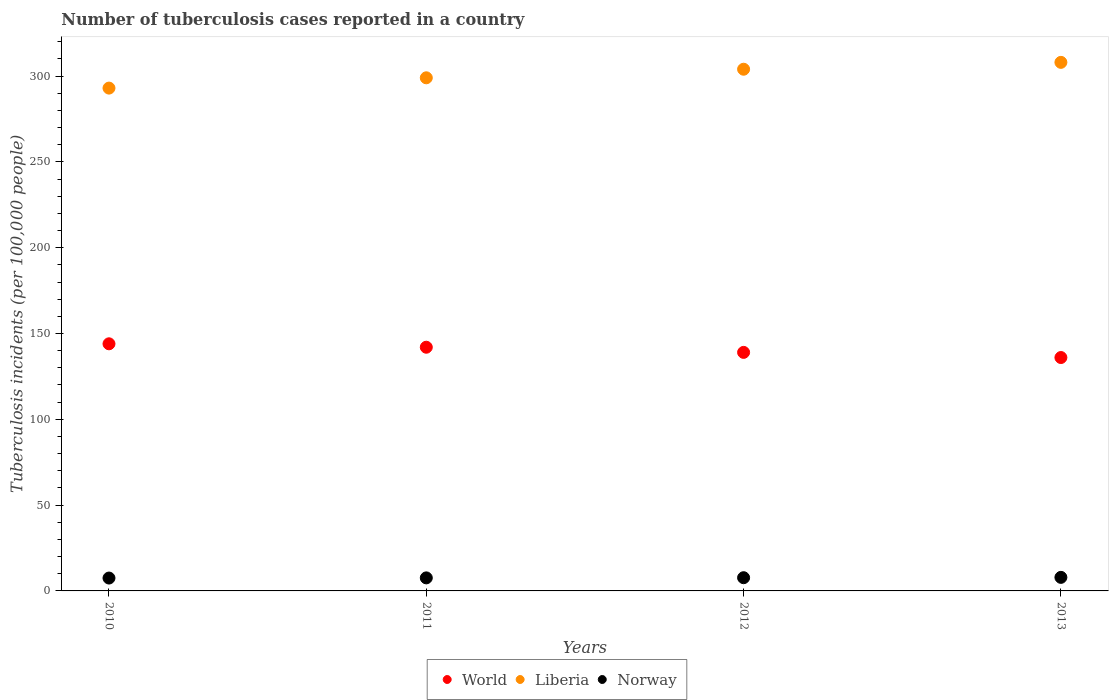How many different coloured dotlines are there?
Ensure brevity in your answer.  3. Across all years, what is the maximum number of tuberculosis cases reported in in Liberia?
Make the answer very short. 308. Across all years, what is the minimum number of tuberculosis cases reported in in Norway?
Keep it short and to the point. 7.5. In which year was the number of tuberculosis cases reported in in Liberia maximum?
Your response must be concise. 2013. What is the total number of tuberculosis cases reported in in World in the graph?
Offer a very short reply. 561. What is the difference between the number of tuberculosis cases reported in in Liberia in 2010 and that in 2012?
Give a very brief answer. -11. What is the difference between the number of tuberculosis cases reported in in Norway in 2013 and the number of tuberculosis cases reported in in Liberia in 2012?
Make the answer very short. -296.1. What is the average number of tuberculosis cases reported in in Liberia per year?
Your answer should be very brief. 301. In the year 2012, what is the difference between the number of tuberculosis cases reported in in Norway and number of tuberculosis cases reported in in Liberia?
Your response must be concise. -296.3. What is the ratio of the number of tuberculosis cases reported in in World in 2010 to that in 2013?
Offer a terse response. 1.06. What is the difference between the highest and the second highest number of tuberculosis cases reported in in Norway?
Give a very brief answer. 0.2. What is the difference between the highest and the lowest number of tuberculosis cases reported in in Norway?
Offer a terse response. 0.4. In how many years, is the number of tuberculosis cases reported in in Liberia greater than the average number of tuberculosis cases reported in in Liberia taken over all years?
Your answer should be compact. 2. Is the sum of the number of tuberculosis cases reported in in Liberia in 2011 and 2013 greater than the maximum number of tuberculosis cases reported in in World across all years?
Your response must be concise. Yes. Is the number of tuberculosis cases reported in in Liberia strictly less than the number of tuberculosis cases reported in in World over the years?
Provide a succinct answer. No. How many dotlines are there?
Make the answer very short. 3. How many years are there in the graph?
Make the answer very short. 4. Are the values on the major ticks of Y-axis written in scientific E-notation?
Your response must be concise. No. Does the graph contain any zero values?
Your response must be concise. No. Where does the legend appear in the graph?
Make the answer very short. Bottom center. How many legend labels are there?
Keep it short and to the point. 3. How are the legend labels stacked?
Make the answer very short. Horizontal. What is the title of the graph?
Ensure brevity in your answer.  Number of tuberculosis cases reported in a country. Does "Lower middle income" appear as one of the legend labels in the graph?
Provide a succinct answer. No. What is the label or title of the X-axis?
Give a very brief answer. Years. What is the label or title of the Y-axis?
Provide a short and direct response. Tuberculosis incidents (per 100,0 people). What is the Tuberculosis incidents (per 100,000 people) in World in 2010?
Your answer should be compact. 144. What is the Tuberculosis incidents (per 100,000 people) in Liberia in 2010?
Offer a very short reply. 293. What is the Tuberculosis incidents (per 100,000 people) of World in 2011?
Provide a short and direct response. 142. What is the Tuberculosis incidents (per 100,000 people) in Liberia in 2011?
Provide a succinct answer. 299. What is the Tuberculosis incidents (per 100,000 people) in World in 2012?
Give a very brief answer. 139. What is the Tuberculosis incidents (per 100,000 people) of Liberia in 2012?
Ensure brevity in your answer.  304. What is the Tuberculosis incidents (per 100,000 people) of Norway in 2012?
Your answer should be very brief. 7.7. What is the Tuberculosis incidents (per 100,000 people) in World in 2013?
Offer a terse response. 136. What is the Tuberculosis incidents (per 100,000 people) of Liberia in 2013?
Give a very brief answer. 308. Across all years, what is the maximum Tuberculosis incidents (per 100,000 people) in World?
Offer a very short reply. 144. Across all years, what is the maximum Tuberculosis incidents (per 100,000 people) in Liberia?
Offer a terse response. 308. Across all years, what is the maximum Tuberculosis incidents (per 100,000 people) of Norway?
Keep it short and to the point. 7.9. Across all years, what is the minimum Tuberculosis incidents (per 100,000 people) in World?
Make the answer very short. 136. Across all years, what is the minimum Tuberculosis incidents (per 100,000 people) of Liberia?
Make the answer very short. 293. Across all years, what is the minimum Tuberculosis incidents (per 100,000 people) of Norway?
Your answer should be very brief. 7.5. What is the total Tuberculosis incidents (per 100,000 people) in World in the graph?
Keep it short and to the point. 561. What is the total Tuberculosis incidents (per 100,000 people) of Liberia in the graph?
Offer a very short reply. 1204. What is the total Tuberculosis incidents (per 100,000 people) of Norway in the graph?
Your answer should be compact. 30.7. What is the difference between the Tuberculosis incidents (per 100,000 people) of World in 2010 and that in 2011?
Your answer should be very brief. 2. What is the difference between the Tuberculosis incidents (per 100,000 people) in Liberia in 2010 and that in 2011?
Your answer should be compact. -6. What is the difference between the Tuberculosis incidents (per 100,000 people) in Liberia in 2010 and that in 2012?
Your response must be concise. -11. What is the difference between the Tuberculosis incidents (per 100,000 people) in Norway in 2010 and that in 2012?
Make the answer very short. -0.2. What is the difference between the Tuberculosis incidents (per 100,000 people) of Norway in 2010 and that in 2013?
Make the answer very short. -0.4. What is the difference between the Tuberculosis incidents (per 100,000 people) of Liberia in 2011 and that in 2012?
Offer a very short reply. -5. What is the difference between the Tuberculosis incidents (per 100,000 people) in World in 2011 and that in 2013?
Ensure brevity in your answer.  6. What is the difference between the Tuberculosis incidents (per 100,000 people) in Liberia in 2011 and that in 2013?
Your answer should be very brief. -9. What is the difference between the Tuberculosis incidents (per 100,000 people) of World in 2010 and the Tuberculosis incidents (per 100,000 people) of Liberia in 2011?
Keep it short and to the point. -155. What is the difference between the Tuberculosis incidents (per 100,000 people) in World in 2010 and the Tuberculosis incidents (per 100,000 people) in Norway in 2011?
Your response must be concise. 136.4. What is the difference between the Tuberculosis incidents (per 100,000 people) in Liberia in 2010 and the Tuberculosis incidents (per 100,000 people) in Norway in 2011?
Provide a short and direct response. 285.4. What is the difference between the Tuberculosis incidents (per 100,000 people) of World in 2010 and the Tuberculosis incidents (per 100,000 people) of Liberia in 2012?
Offer a very short reply. -160. What is the difference between the Tuberculosis incidents (per 100,000 people) of World in 2010 and the Tuberculosis incidents (per 100,000 people) of Norway in 2012?
Provide a succinct answer. 136.3. What is the difference between the Tuberculosis incidents (per 100,000 people) in Liberia in 2010 and the Tuberculosis incidents (per 100,000 people) in Norway in 2012?
Provide a short and direct response. 285.3. What is the difference between the Tuberculosis incidents (per 100,000 people) in World in 2010 and the Tuberculosis incidents (per 100,000 people) in Liberia in 2013?
Make the answer very short. -164. What is the difference between the Tuberculosis incidents (per 100,000 people) of World in 2010 and the Tuberculosis incidents (per 100,000 people) of Norway in 2013?
Provide a succinct answer. 136.1. What is the difference between the Tuberculosis incidents (per 100,000 people) in Liberia in 2010 and the Tuberculosis incidents (per 100,000 people) in Norway in 2013?
Provide a succinct answer. 285.1. What is the difference between the Tuberculosis incidents (per 100,000 people) in World in 2011 and the Tuberculosis incidents (per 100,000 people) in Liberia in 2012?
Give a very brief answer. -162. What is the difference between the Tuberculosis incidents (per 100,000 people) of World in 2011 and the Tuberculosis incidents (per 100,000 people) of Norway in 2012?
Your answer should be very brief. 134.3. What is the difference between the Tuberculosis incidents (per 100,000 people) of Liberia in 2011 and the Tuberculosis incidents (per 100,000 people) of Norway in 2012?
Your answer should be very brief. 291.3. What is the difference between the Tuberculosis incidents (per 100,000 people) of World in 2011 and the Tuberculosis incidents (per 100,000 people) of Liberia in 2013?
Your answer should be compact. -166. What is the difference between the Tuberculosis incidents (per 100,000 people) in World in 2011 and the Tuberculosis incidents (per 100,000 people) in Norway in 2013?
Ensure brevity in your answer.  134.1. What is the difference between the Tuberculosis incidents (per 100,000 people) of Liberia in 2011 and the Tuberculosis incidents (per 100,000 people) of Norway in 2013?
Give a very brief answer. 291.1. What is the difference between the Tuberculosis incidents (per 100,000 people) of World in 2012 and the Tuberculosis incidents (per 100,000 people) of Liberia in 2013?
Your answer should be compact. -169. What is the difference between the Tuberculosis incidents (per 100,000 people) of World in 2012 and the Tuberculosis incidents (per 100,000 people) of Norway in 2013?
Keep it short and to the point. 131.1. What is the difference between the Tuberculosis incidents (per 100,000 people) of Liberia in 2012 and the Tuberculosis incidents (per 100,000 people) of Norway in 2013?
Make the answer very short. 296.1. What is the average Tuberculosis incidents (per 100,000 people) in World per year?
Give a very brief answer. 140.25. What is the average Tuberculosis incidents (per 100,000 people) of Liberia per year?
Make the answer very short. 301. What is the average Tuberculosis incidents (per 100,000 people) of Norway per year?
Give a very brief answer. 7.67. In the year 2010, what is the difference between the Tuberculosis incidents (per 100,000 people) in World and Tuberculosis incidents (per 100,000 people) in Liberia?
Give a very brief answer. -149. In the year 2010, what is the difference between the Tuberculosis incidents (per 100,000 people) of World and Tuberculosis incidents (per 100,000 people) of Norway?
Provide a succinct answer. 136.5. In the year 2010, what is the difference between the Tuberculosis incidents (per 100,000 people) of Liberia and Tuberculosis incidents (per 100,000 people) of Norway?
Your answer should be compact. 285.5. In the year 2011, what is the difference between the Tuberculosis incidents (per 100,000 people) of World and Tuberculosis incidents (per 100,000 people) of Liberia?
Your response must be concise. -157. In the year 2011, what is the difference between the Tuberculosis incidents (per 100,000 people) in World and Tuberculosis incidents (per 100,000 people) in Norway?
Your answer should be compact. 134.4. In the year 2011, what is the difference between the Tuberculosis incidents (per 100,000 people) of Liberia and Tuberculosis incidents (per 100,000 people) of Norway?
Give a very brief answer. 291.4. In the year 2012, what is the difference between the Tuberculosis incidents (per 100,000 people) of World and Tuberculosis incidents (per 100,000 people) of Liberia?
Keep it short and to the point. -165. In the year 2012, what is the difference between the Tuberculosis incidents (per 100,000 people) in World and Tuberculosis incidents (per 100,000 people) in Norway?
Keep it short and to the point. 131.3. In the year 2012, what is the difference between the Tuberculosis incidents (per 100,000 people) in Liberia and Tuberculosis incidents (per 100,000 people) in Norway?
Give a very brief answer. 296.3. In the year 2013, what is the difference between the Tuberculosis incidents (per 100,000 people) in World and Tuberculosis incidents (per 100,000 people) in Liberia?
Your response must be concise. -172. In the year 2013, what is the difference between the Tuberculosis incidents (per 100,000 people) in World and Tuberculosis incidents (per 100,000 people) in Norway?
Keep it short and to the point. 128.1. In the year 2013, what is the difference between the Tuberculosis incidents (per 100,000 people) of Liberia and Tuberculosis incidents (per 100,000 people) of Norway?
Offer a terse response. 300.1. What is the ratio of the Tuberculosis incidents (per 100,000 people) of World in 2010 to that in 2011?
Provide a short and direct response. 1.01. What is the ratio of the Tuberculosis incidents (per 100,000 people) of Liberia in 2010 to that in 2011?
Offer a terse response. 0.98. What is the ratio of the Tuberculosis incidents (per 100,000 people) of Norway in 2010 to that in 2011?
Ensure brevity in your answer.  0.99. What is the ratio of the Tuberculosis incidents (per 100,000 people) in World in 2010 to that in 2012?
Ensure brevity in your answer.  1.04. What is the ratio of the Tuberculosis incidents (per 100,000 people) in Liberia in 2010 to that in 2012?
Your answer should be compact. 0.96. What is the ratio of the Tuberculosis incidents (per 100,000 people) in World in 2010 to that in 2013?
Provide a short and direct response. 1.06. What is the ratio of the Tuberculosis incidents (per 100,000 people) of Liberia in 2010 to that in 2013?
Provide a short and direct response. 0.95. What is the ratio of the Tuberculosis incidents (per 100,000 people) of Norway in 2010 to that in 2013?
Offer a very short reply. 0.95. What is the ratio of the Tuberculosis incidents (per 100,000 people) of World in 2011 to that in 2012?
Ensure brevity in your answer.  1.02. What is the ratio of the Tuberculosis incidents (per 100,000 people) of Liberia in 2011 to that in 2012?
Offer a terse response. 0.98. What is the ratio of the Tuberculosis incidents (per 100,000 people) of World in 2011 to that in 2013?
Give a very brief answer. 1.04. What is the ratio of the Tuberculosis incidents (per 100,000 people) in Liberia in 2011 to that in 2013?
Provide a short and direct response. 0.97. What is the ratio of the Tuberculosis incidents (per 100,000 people) of Norway in 2011 to that in 2013?
Provide a short and direct response. 0.96. What is the ratio of the Tuberculosis incidents (per 100,000 people) of World in 2012 to that in 2013?
Make the answer very short. 1.02. What is the ratio of the Tuberculosis incidents (per 100,000 people) in Norway in 2012 to that in 2013?
Provide a succinct answer. 0.97. What is the difference between the highest and the second highest Tuberculosis incidents (per 100,000 people) in World?
Your answer should be compact. 2. What is the difference between the highest and the second highest Tuberculosis incidents (per 100,000 people) of Liberia?
Provide a succinct answer. 4. What is the difference between the highest and the lowest Tuberculosis incidents (per 100,000 people) of World?
Offer a very short reply. 8. What is the difference between the highest and the lowest Tuberculosis incidents (per 100,000 people) of Norway?
Ensure brevity in your answer.  0.4. 